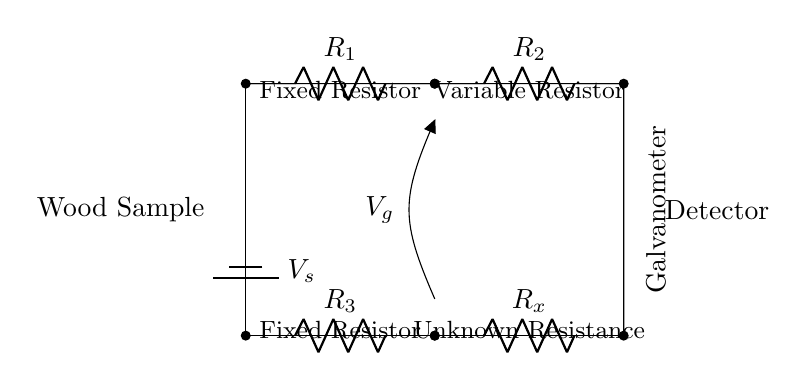What is the voltage source in this circuit? The voltage source is denoted as V_s, which is indicated next to the battery symbol in the circuit diagram.
Answer: V_s What does R_x represent in this circuit? R_x represents the unknown resistance of the wood sample being tested for moisture content. It is the variable resistor in the bottom branch of the bridge circuit.
Answer: Unknown Resistance How many resistors are present in this circuit? There are a total of four resistors: two fixed resistors (R_1 and R_3) and two resistors that can vary (R_2 and R_x).
Answer: Four What is the function of the galvanometer in this circuit? The galvanometer is used to detect the voltage difference across the bridge, indicating whether the circuit is balanced or not based on the moisture content.
Answer: Detection What is the significance of balancing the bridge circuit? Balancing the bridge circuit allows for accurate measurements of the unknown resistance (R_x), which correlates directly to the moisture content of the wood sample. When balanced, the voltage across the galvanometer will be zero.
Answer: Accurate Measurement What type of circuit is this classified as? This circuit is classified as a bridge circuit, specifically a Wheatstone bridge type used for measuring resistances accurately.
Answer: Bridge Circuit 